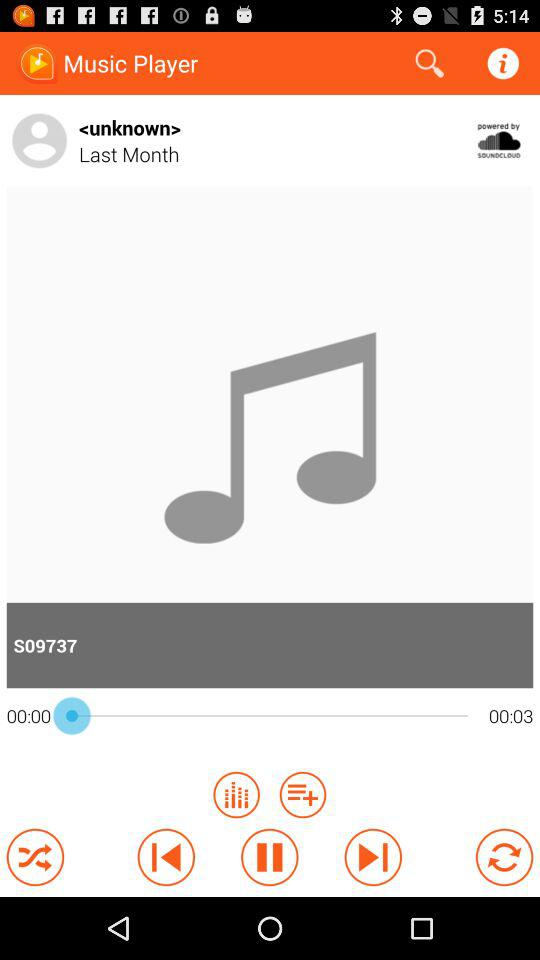How many seconds are between the two timestamps?
Answer the question using a single word or phrase. 3 